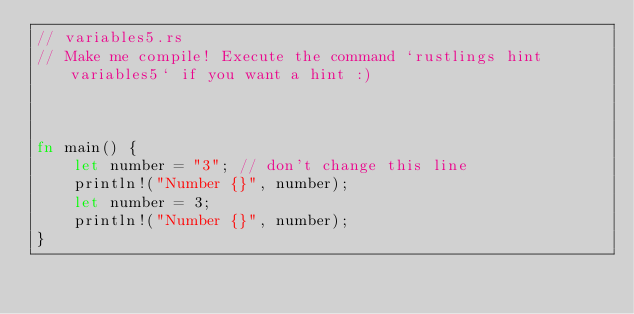Convert code to text. <code><loc_0><loc_0><loc_500><loc_500><_Rust_>// variables5.rs
// Make me compile! Execute the command `rustlings hint variables5` if you want a hint :)



fn main() {
    let number = "3"; // don't change this line
    println!("Number {}", number);
    let number = 3;
    println!("Number {}", number);
}
</code> 